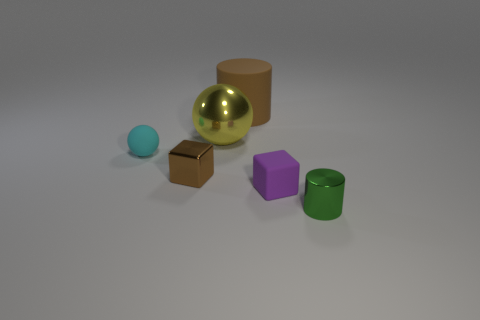Subtract 1 purple blocks. How many objects are left? 5 Subtract all spheres. How many objects are left? 4 Subtract all brown cylinders. Subtract all red cubes. How many cylinders are left? 1 Subtract all green balls. How many red cylinders are left? 0 Subtract all brown rubber cylinders. Subtract all tiny objects. How many objects are left? 1 Add 1 yellow metal things. How many yellow metal things are left? 2 Add 5 cylinders. How many cylinders exist? 7 Add 3 large metal objects. How many objects exist? 9 